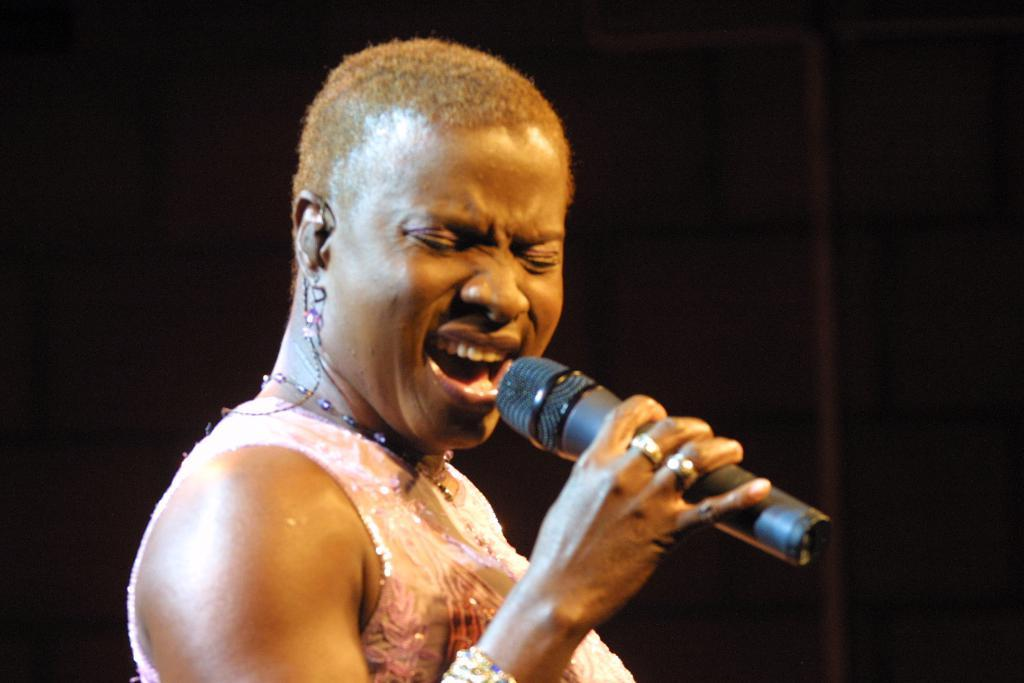What is the main subject of the image? The main subject of the image is a woman. What is the woman holding in the image? The woman is holding a mic. What type of hydrant can be seen in the background of the image? There is no hydrant present in the image. What color are the bubbles floating around the woman in the image? There are no bubbles present in the image. 